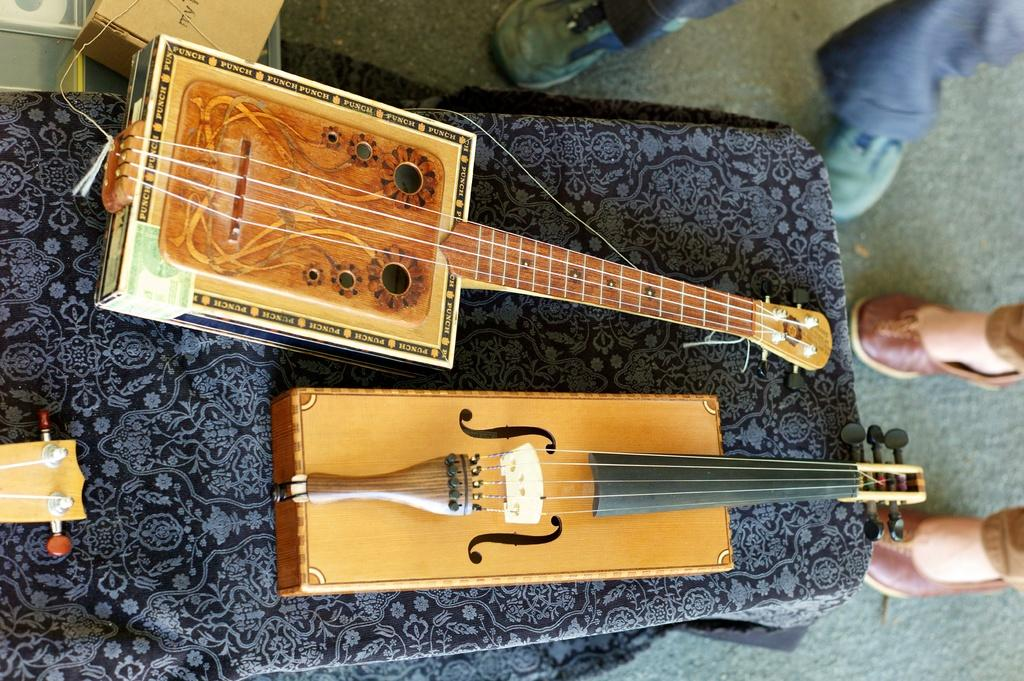What objects are on the table in the image? There are guitars on a table in the image. What else can be seen in the image besides the guitars? There are people standing near the table in the image. Can you describe any other objects in the image? Yes, there is a box in the image. What type of government is depicted in the image? There is no depiction of a government in the image; it features guitars, people, and a box. How many tomatoes are visible in the image? There are no tomatoes present in the image. 